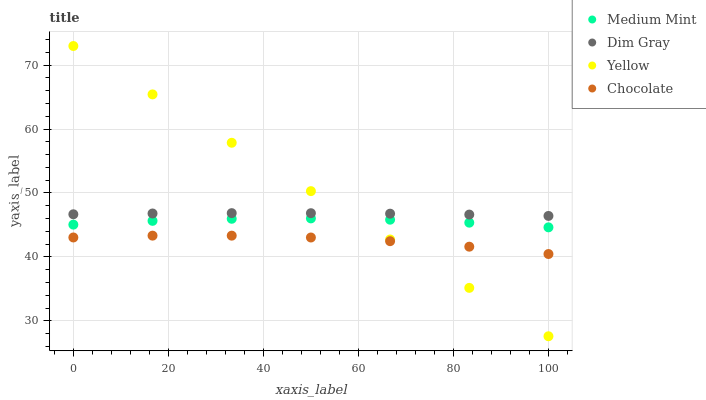Does Chocolate have the minimum area under the curve?
Answer yes or no. Yes. Does Yellow have the maximum area under the curve?
Answer yes or no. Yes. Does Dim Gray have the minimum area under the curve?
Answer yes or no. No. Does Dim Gray have the maximum area under the curve?
Answer yes or no. No. Is Yellow the smoothest?
Answer yes or no. Yes. Is Chocolate the roughest?
Answer yes or no. Yes. Is Dim Gray the smoothest?
Answer yes or no. No. Is Dim Gray the roughest?
Answer yes or no. No. Does Yellow have the lowest value?
Answer yes or no. Yes. Does Dim Gray have the lowest value?
Answer yes or no. No. Does Yellow have the highest value?
Answer yes or no. Yes. Does Dim Gray have the highest value?
Answer yes or no. No. Is Medium Mint less than Dim Gray?
Answer yes or no. Yes. Is Medium Mint greater than Chocolate?
Answer yes or no. Yes. Does Yellow intersect Dim Gray?
Answer yes or no. Yes. Is Yellow less than Dim Gray?
Answer yes or no. No. Is Yellow greater than Dim Gray?
Answer yes or no. No. Does Medium Mint intersect Dim Gray?
Answer yes or no. No. 